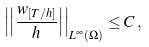<formula> <loc_0><loc_0><loc_500><loc_500>\left | \left | \frac { w _ { [ T / h ] } } { h } \right | \right | _ { L ^ { \infty } ( \Omega ) } \leq C \, ,</formula> 